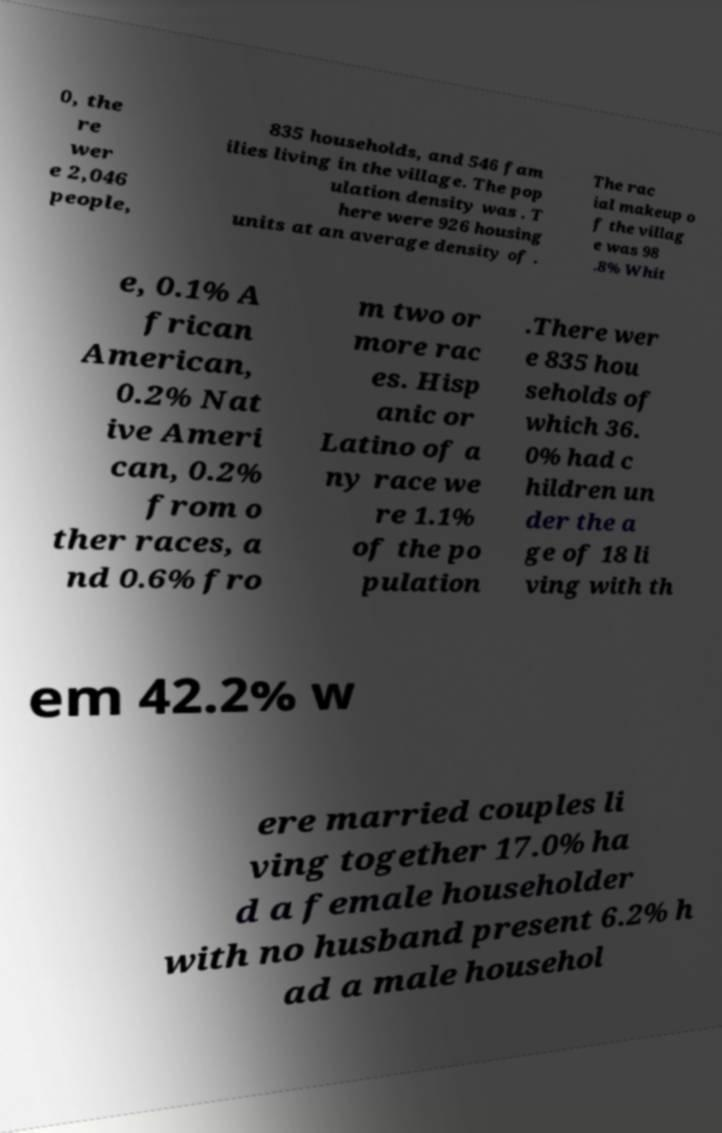Could you assist in decoding the text presented in this image and type it out clearly? 0, the re wer e 2,046 people, 835 households, and 546 fam ilies living in the village. The pop ulation density was . T here were 926 housing units at an average density of . The rac ial makeup o f the villag e was 98 .8% Whit e, 0.1% A frican American, 0.2% Nat ive Ameri can, 0.2% from o ther races, a nd 0.6% fro m two or more rac es. Hisp anic or Latino of a ny race we re 1.1% of the po pulation .There wer e 835 hou seholds of which 36. 0% had c hildren un der the a ge of 18 li ving with th em 42.2% w ere married couples li ving together 17.0% ha d a female householder with no husband present 6.2% h ad a male househol 